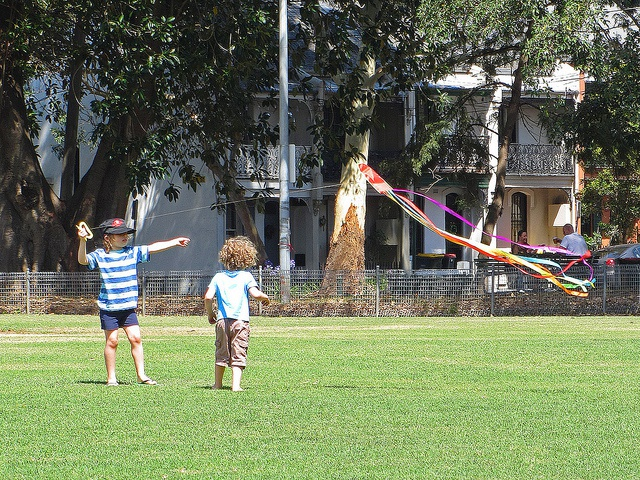Describe the objects in this image and their specific colors. I can see people in black, white, gray, and lightblue tones, kite in black, white, gray, and maroon tones, people in black, white, gray, and olive tones, car in black, gray, and darkgray tones, and people in black, darkgray, gray, and lavender tones in this image. 